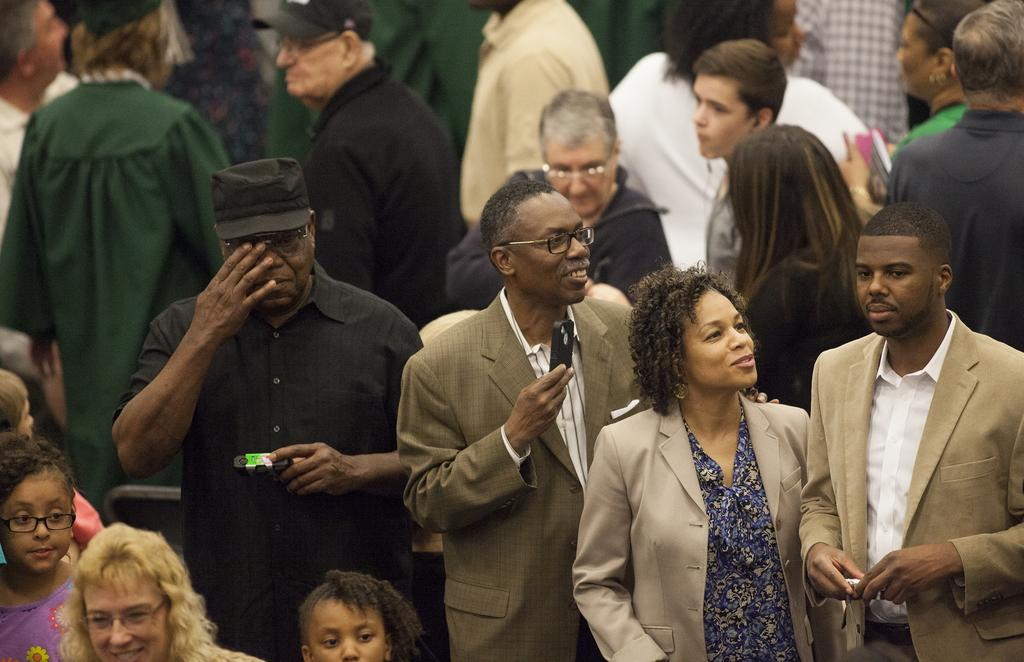What are the people in the image doing? The persons in the image are standing. What type of clothing can be seen on some of the persons? Some of the persons are wearing coats and hats. What accessories are visible on some of the persons? Some of the persons are wearing spectacles. What items are being held by some of the persons? Some of the persons are holding books, mobile phones, and other objects. What is the tax rate for the bee in the image? There is no bee present in the image, and therefore no tax rate can be determined. How many coats is the coat wearing in the image? The question is unclear and seems to be a trick question, as coats are worn by people, not other coats. In the image, some persons are wearing coats, but the coats themselves are not wearing any clothing. 